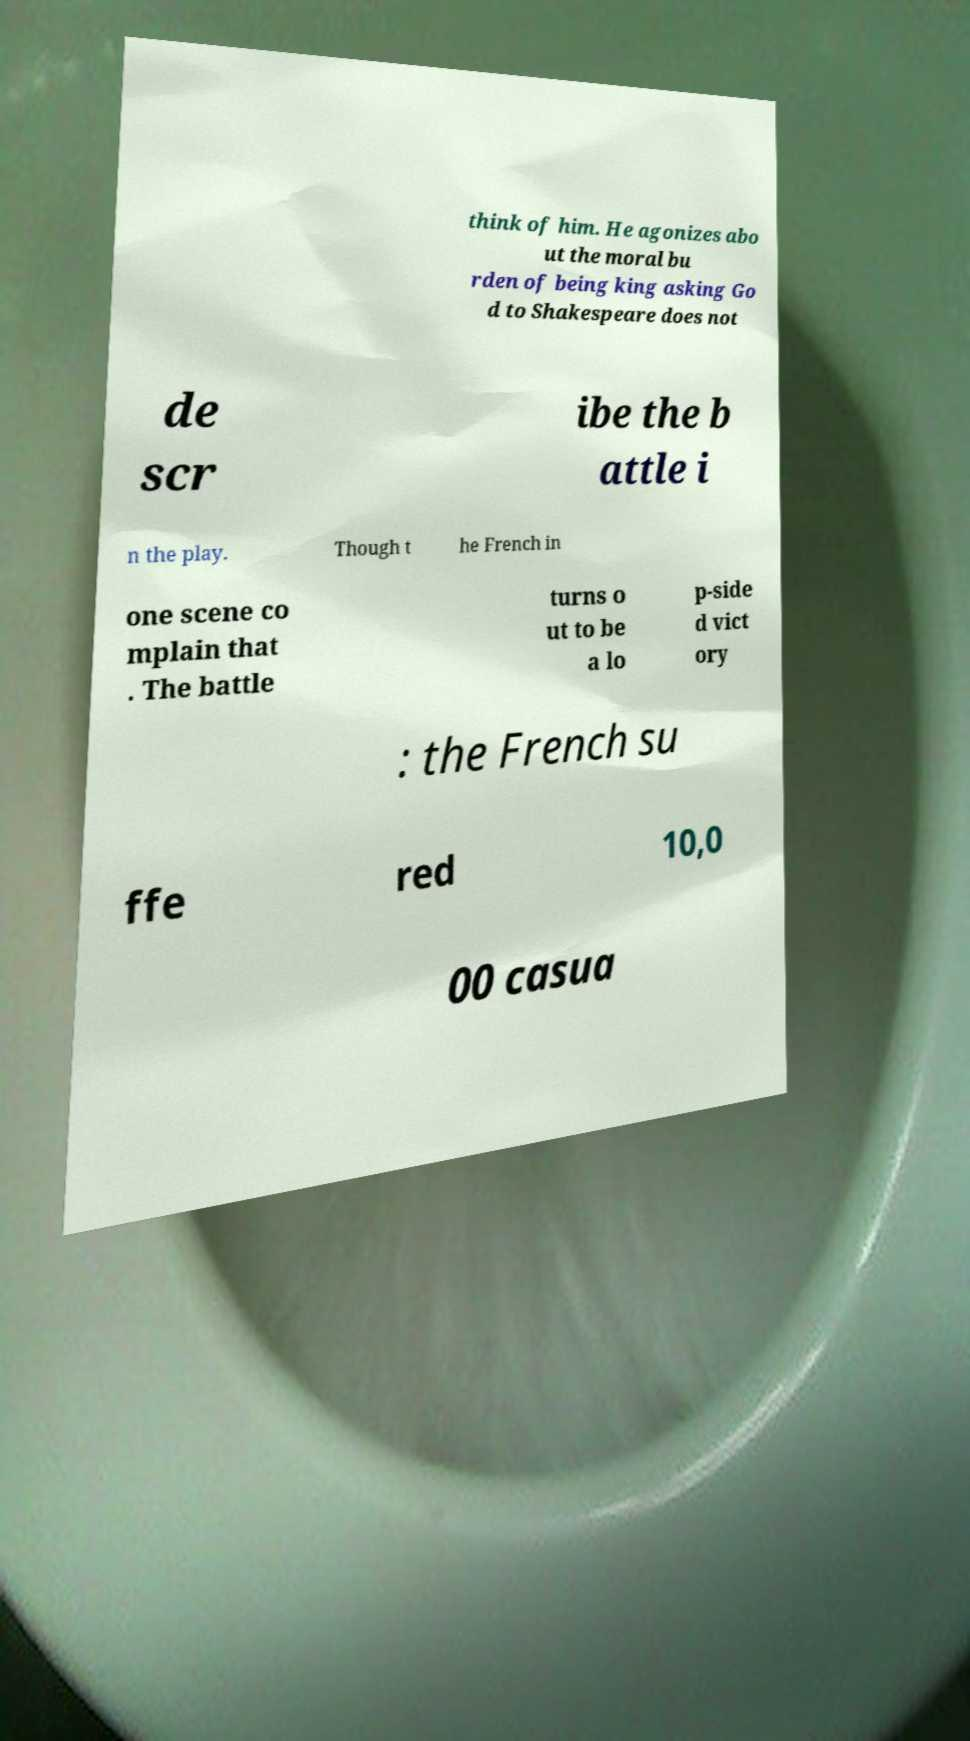For documentation purposes, I need the text within this image transcribed. Could you provide that? think of him. He agonizes abo ut the moral bu rden of being king asking Go d to Shakespeare does not de scr ibe the b attle i n the play. Though t he French in one scene co mplain that . The battle turns o ut to be a lo p-side d vict ory : the French su ffe red 10,0 00 casua 